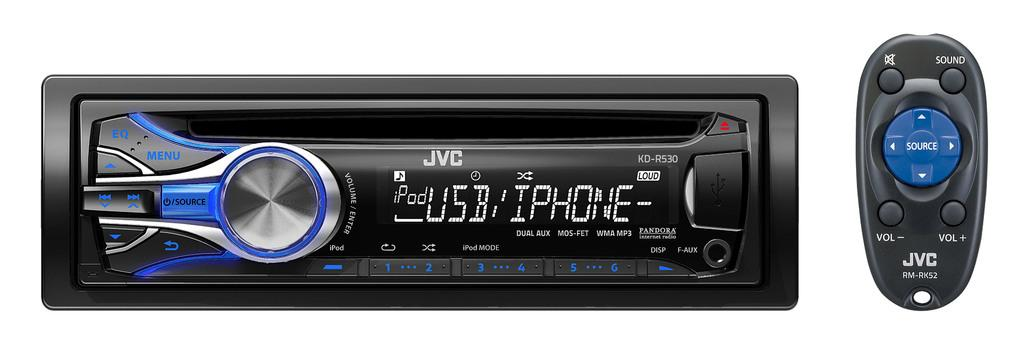Provide a one-sentence caption for the provided image. the car radio display shows that is connects to a phone with usb. 